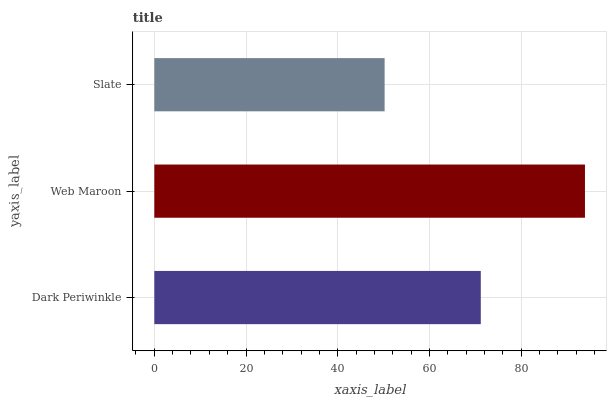Is Slate the minimum?
Answer yes or no. Yes. Is Web Maroon the maximum?
Answer yes or no. Yes. Is Web Maroon the minimum?
Answer yes or no. No. Is Slate the maximum?
Answer yes or no. No. Is Web Maroon greater than Slate?
Answer yes or no. Yes. Is Slate less than Web Maroon?
Answer yes or no. Yes. Is Slate greater than Web Maroon?
Answer yes or no. No. Is Web Maroon less than Slate?
Answer yes or no. No. Is Dark Periwinkle the high median?
Answer yes or no. Yes. Is Dark Periwinkle the low median?
Answer yes or no. Yes. Is Slate the high median?
Answer yes or no. No. Is Slate the low median?
Answer yes or no. No. 